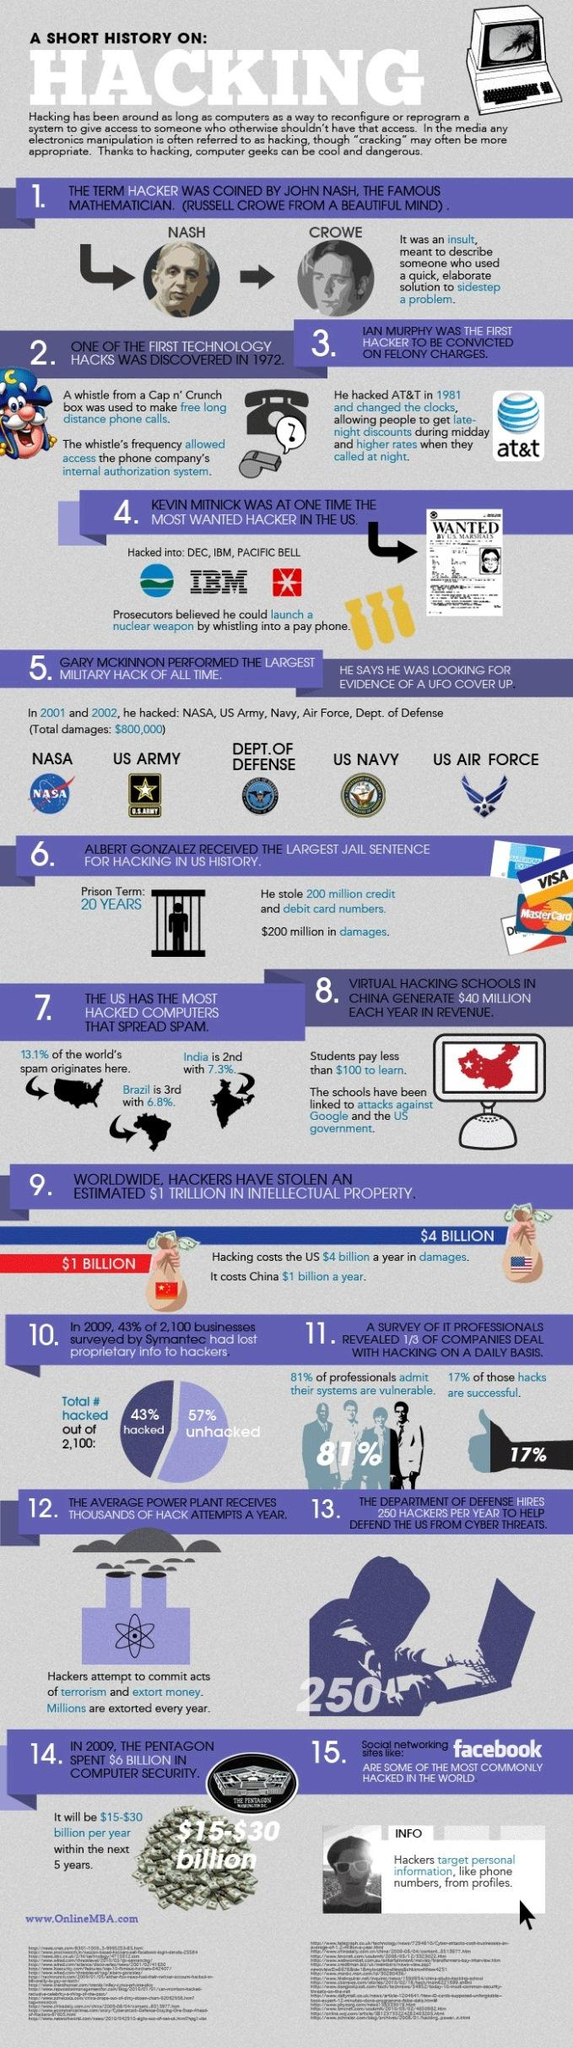List a handful of essential elements in this visual. According to recent statistics, approximately 13.1% of spam originates from the United States. 83% of hacks were unsuccessful. Albert Gonzalez was in jail for a period of 20 years. 